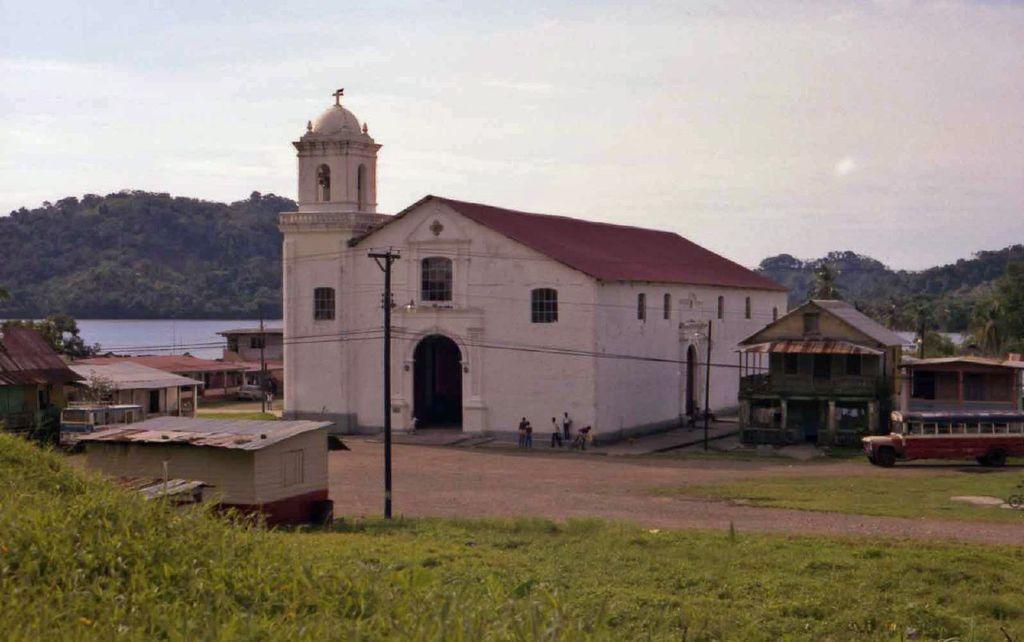Could you give a brief overview of what you see in this image? In this picture there are houses in the center of the image and there is grassland at the bottom side of the image, there are trees in the background area of the image. 